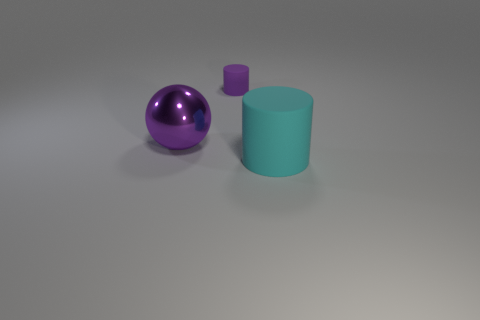Add 3 brown rubber cubes. How many objects exist? 6 Subtract all balls. How many objects are left? 2 Subtract all brown spheres. How many purple cylinders are left? 1 Subtract all large shiny spheres. Subtract all cylinders. How many objects are left? 0 Add 3 shiny objects. How many shiny objects are left? 4 Add 1 cyan matte blocks. How many cyan matte blocks exist? 1 Subtract all purple cylinders. How many cylinders are left? 1 Subtract 1 cyan cylinders. How many objects are left? 2 Subtract 1 spheres. How many spheres are left? 0 Subtract all green cylinders. Subtract all yellow cubes. How many cylinders are left? 2 